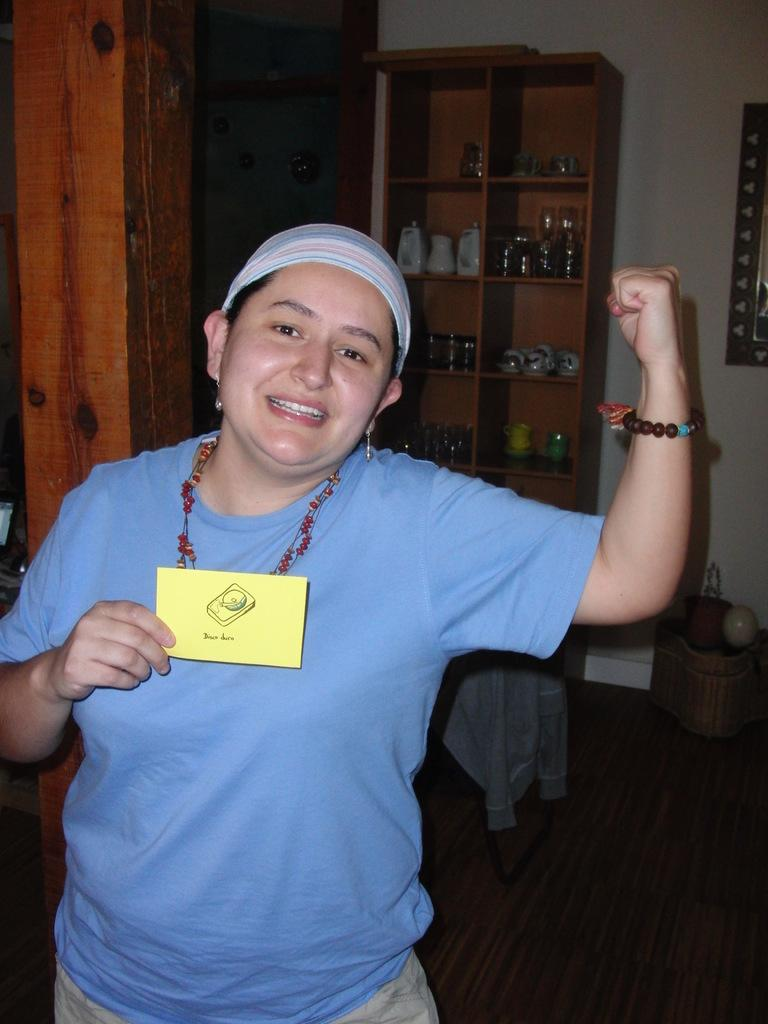Who is present in the image? There is a person in the image. What is the person wearing on their head? The person is wearing a cap. What is the person holding in their hand? The person is holding a card. What can be seen in the background of the image? There are shelves in the background of the image. What is placed on the shelves? There are items placed on the shelves. How many boys are present in the image? There is no mention of a boy in the image; only a person is mentioned. 